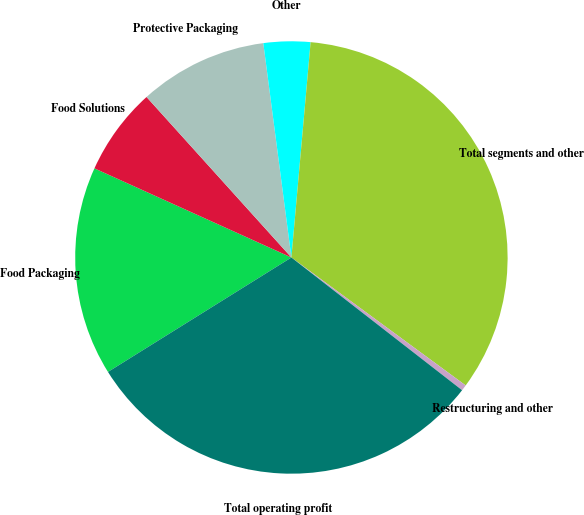Convert chart. <chart><loc_0><loc_0><loc_500><loc_500><pie_chart><fcel>Food Packaging<fcel>Food Solutions<fcel>Protective Packaging<fcel>Other<fcel>Total segments and other<fcel>Restructuring and other<fcel>Total operating profit<nl><fcel>15.64%<fcel>6.55%<fcel>9.61%<fcel>3.49%<fcel>33.66%<fcel>0.44%<fcel>30.6%<nl></chart> 